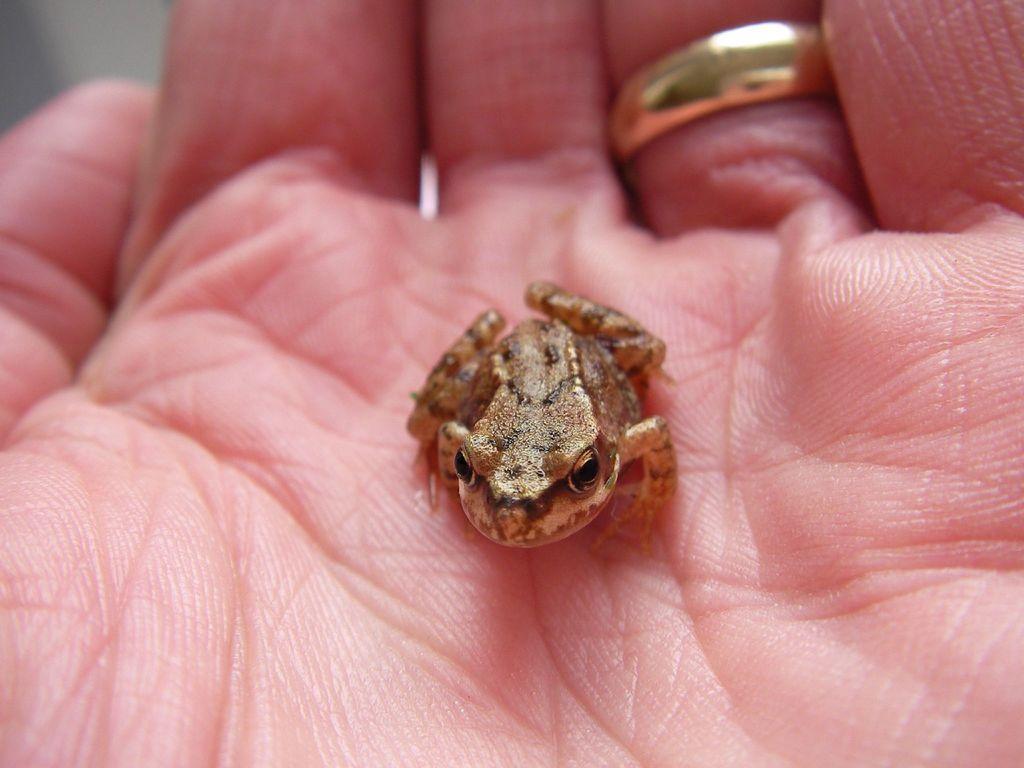Please provide a concise description of this image. In the image there is palm of a person and there is a ring to the one of the finger and there is a frog on the palm. 